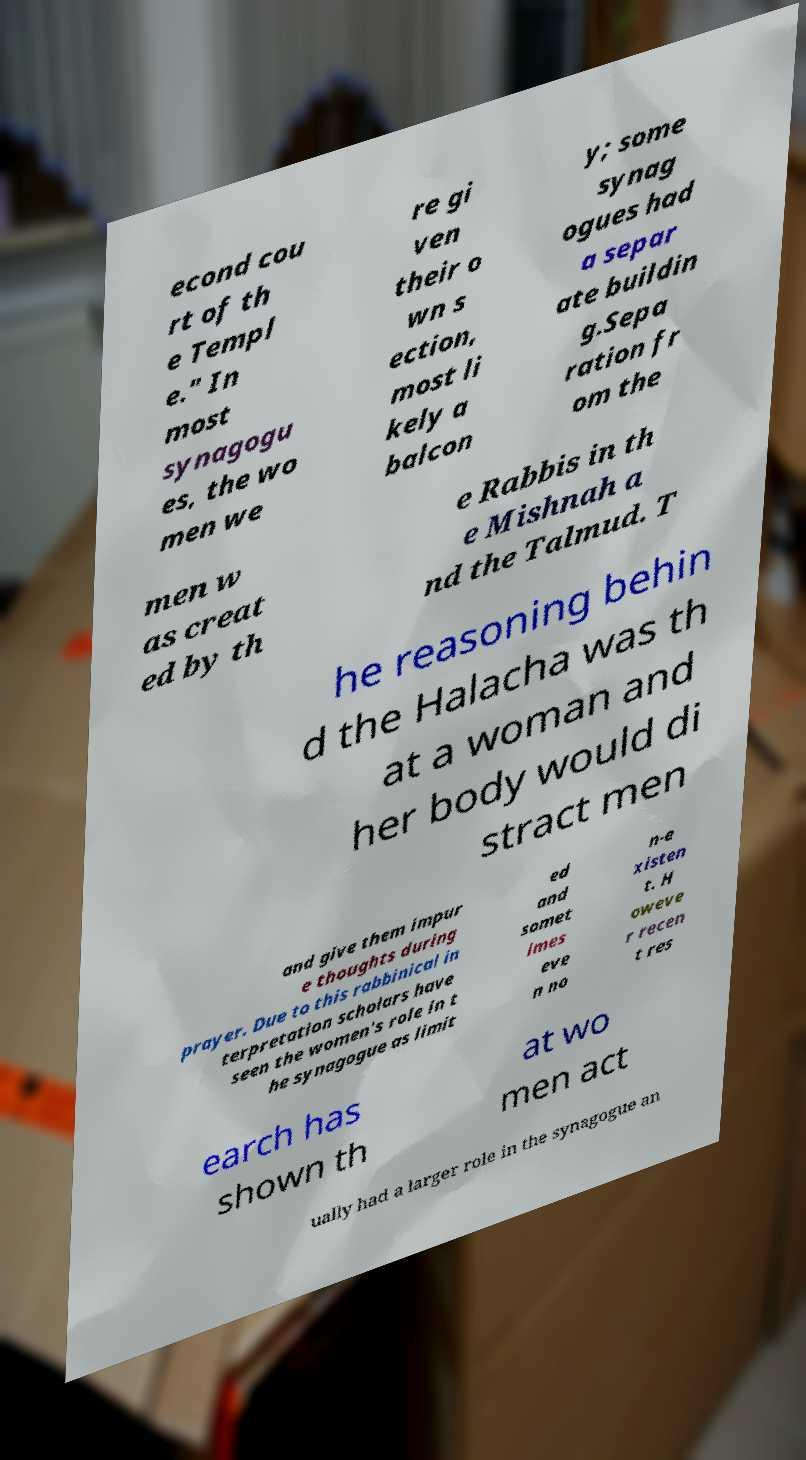Could you extract and type out the text from this image? econd cou rt of th e Templ e." In most synagogu es, the wo men we re gi ven their o wn s ection, most li kely a balcon y; some synag ogues had a separ ate buildin g.Sepa ration fr om the men w as creat ed by th e Rabbis in th e Mishnah a nd the Talmud. T he reasoning behin d the Halacha was th at a woman and her body would di stract men and give them impur e thoughts during prayer. Due to this rabbinical in terpretation scholars have seen the women's role in t he synagogue as limit ed and somet imes eve n no n-e xisten t. H oweve r recen t res earch has shown th at wo men act ually had a larger role in the synagogue an 